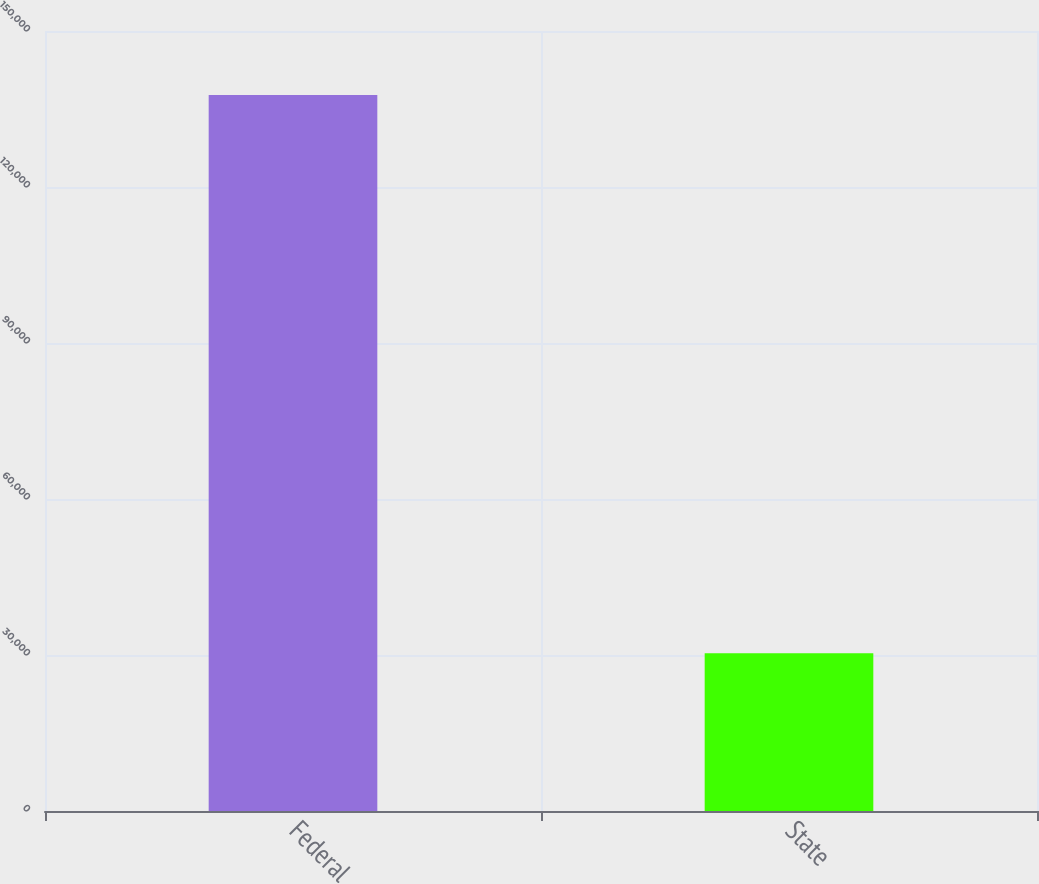Convert chart to OTSL. <chart><loc_0><loc_0><loc_500><loc_500><bar_chart><fcel>Federal<fcel>State<nl><fcel>137675<fcel>30352<nl></chart> 